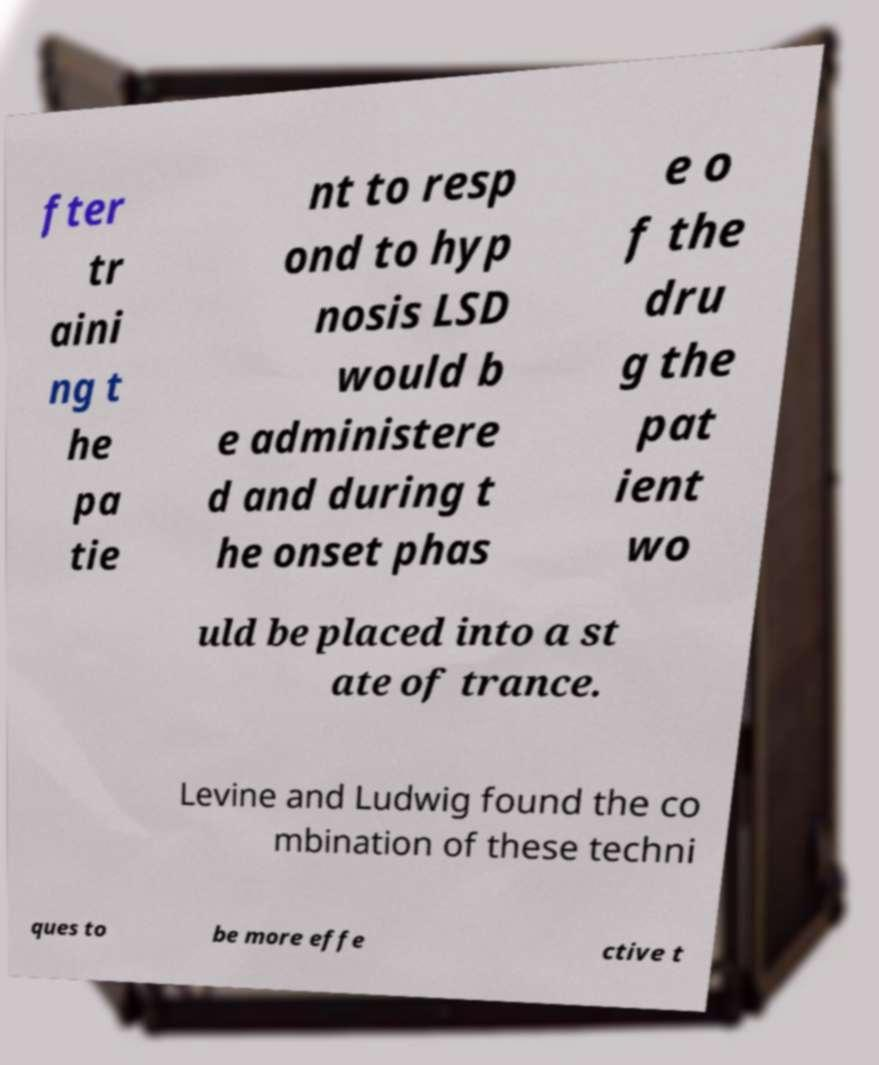Could you extract and type out the text from this image? fter tr aini ng t he pa tie nt to resp ond to hyp nosis LSD would b e administere d and during t he onset phas e o f the dru g the pat ient wo uld be placed into a st ate of trance. Levine and Ludwig found the co mbination of these techni ques to be more effe ctive t 